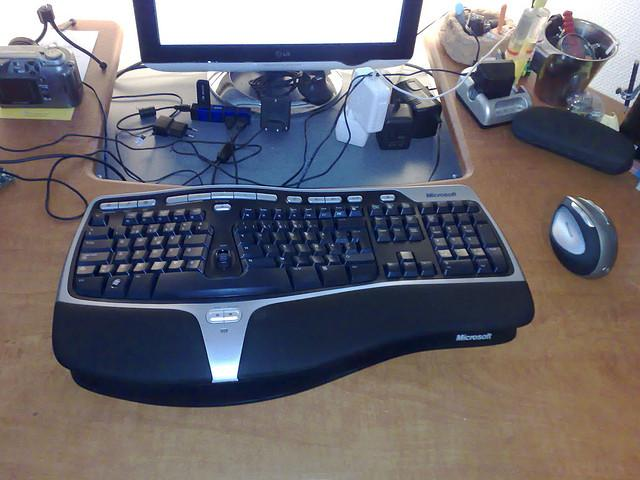What are the corded objects used for?

Choices:
A) dividing objects
B) powering devices
C) organizing objects
D) testing voltage powering devices 